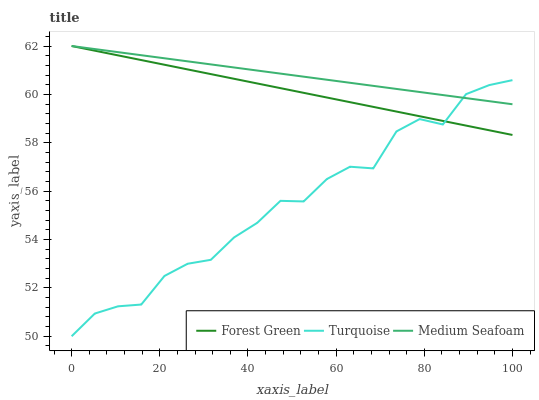Does Turquoise have the minimum area under the curve?
Answer yes or no. Yes. Does Medium Seafoam have the maximum area under the curve?
Answer yes or no. Yes. Does Medium Seafoam have the minimum area under the curve?
Answer yes or no. No. Does Turquoise have the maximum area under the curve?
Answer yes or no. No. Is Forest Green the smoothest?
Answer yes or no. Yes. Is Turquoise the roughest?
Answer yes or no. Yes. Is Medium Seafoam the smoothest?
Answer yes or no. No. Is Medium Seafoam the roughest?
Answer yes or no. No. Does Medium Seafoam have the lowest value?
Answer yes or no. No. Does Medium Seafoam have the highest value?
Answer yes or no. Yes. Does Turquoise have the highest value?
Answer yes or no. No. 